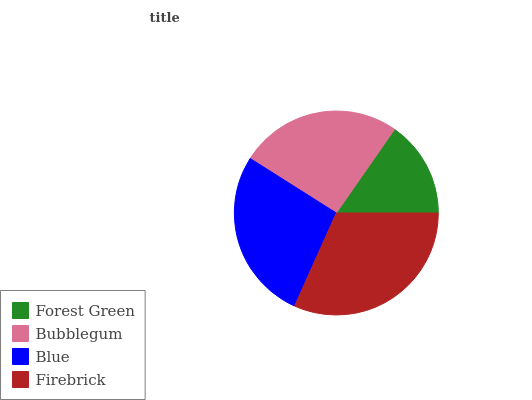Is Forest Green the minimum?
Answer yes or no. Yes. Is Firebrick the maximum?
Answer yes or no. Yes. Is Bubblegum the minimum?
Answer yes or no. No. Is Bubblegum the maximum?
Answer yes or no. No. Is Bubblegum greater than Forest Green?
Answer yes or no. Yes. Is Forest Green less than Bubblegum?
Answer yes or no. Yes. Is Forest Green greater than Bubblegum?
Answer yes or no. No. Is Bubblegum less than Forest Green?
Answer yes or no. No. Is Blue the high median?
Answer yes or no. Yes. Is Bubblegum the low median?
Answer yes or no. Yes. Is Bubblegum the high median?
Answer yes or no. No. Is Forest Green the low median?
Answer yes or no. No. 